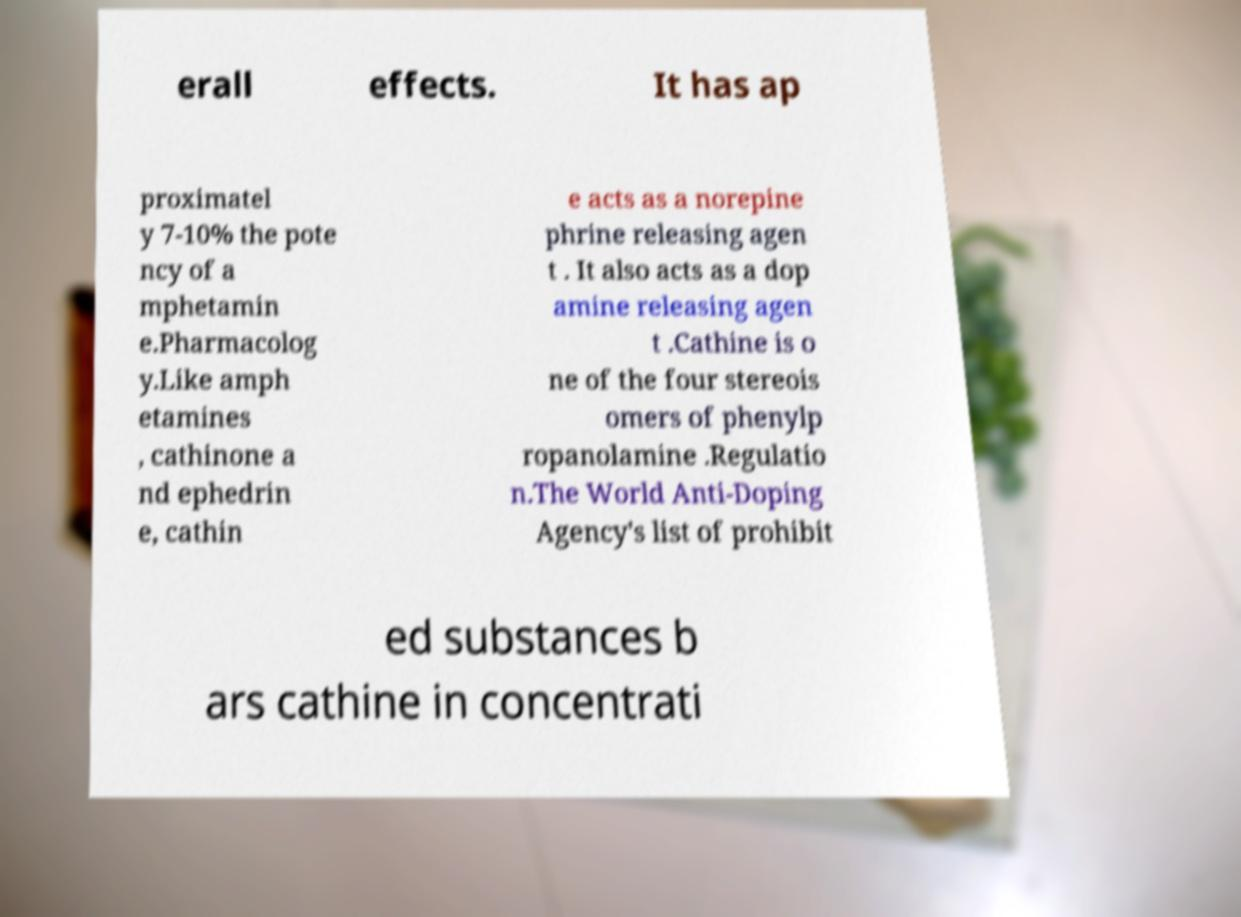Can you accurately transcribe the text from the provided image for me? erall effects. It has ap proximatel y 7-10% the pote ncy of a mphetamin e.Pharmacolog y.Like amph etamines , cathinone a nd ephedrin e, cathin e acts as a norepine phrine releasing agen t . It also acts as a dop amine releasing agen t .Cathine is o ne of the four stereois omers of phenylp ropanolamine .Regulatio n.The World Anti-Doping Agency's list of prohibit ed substances b ars cathine in concentrati 